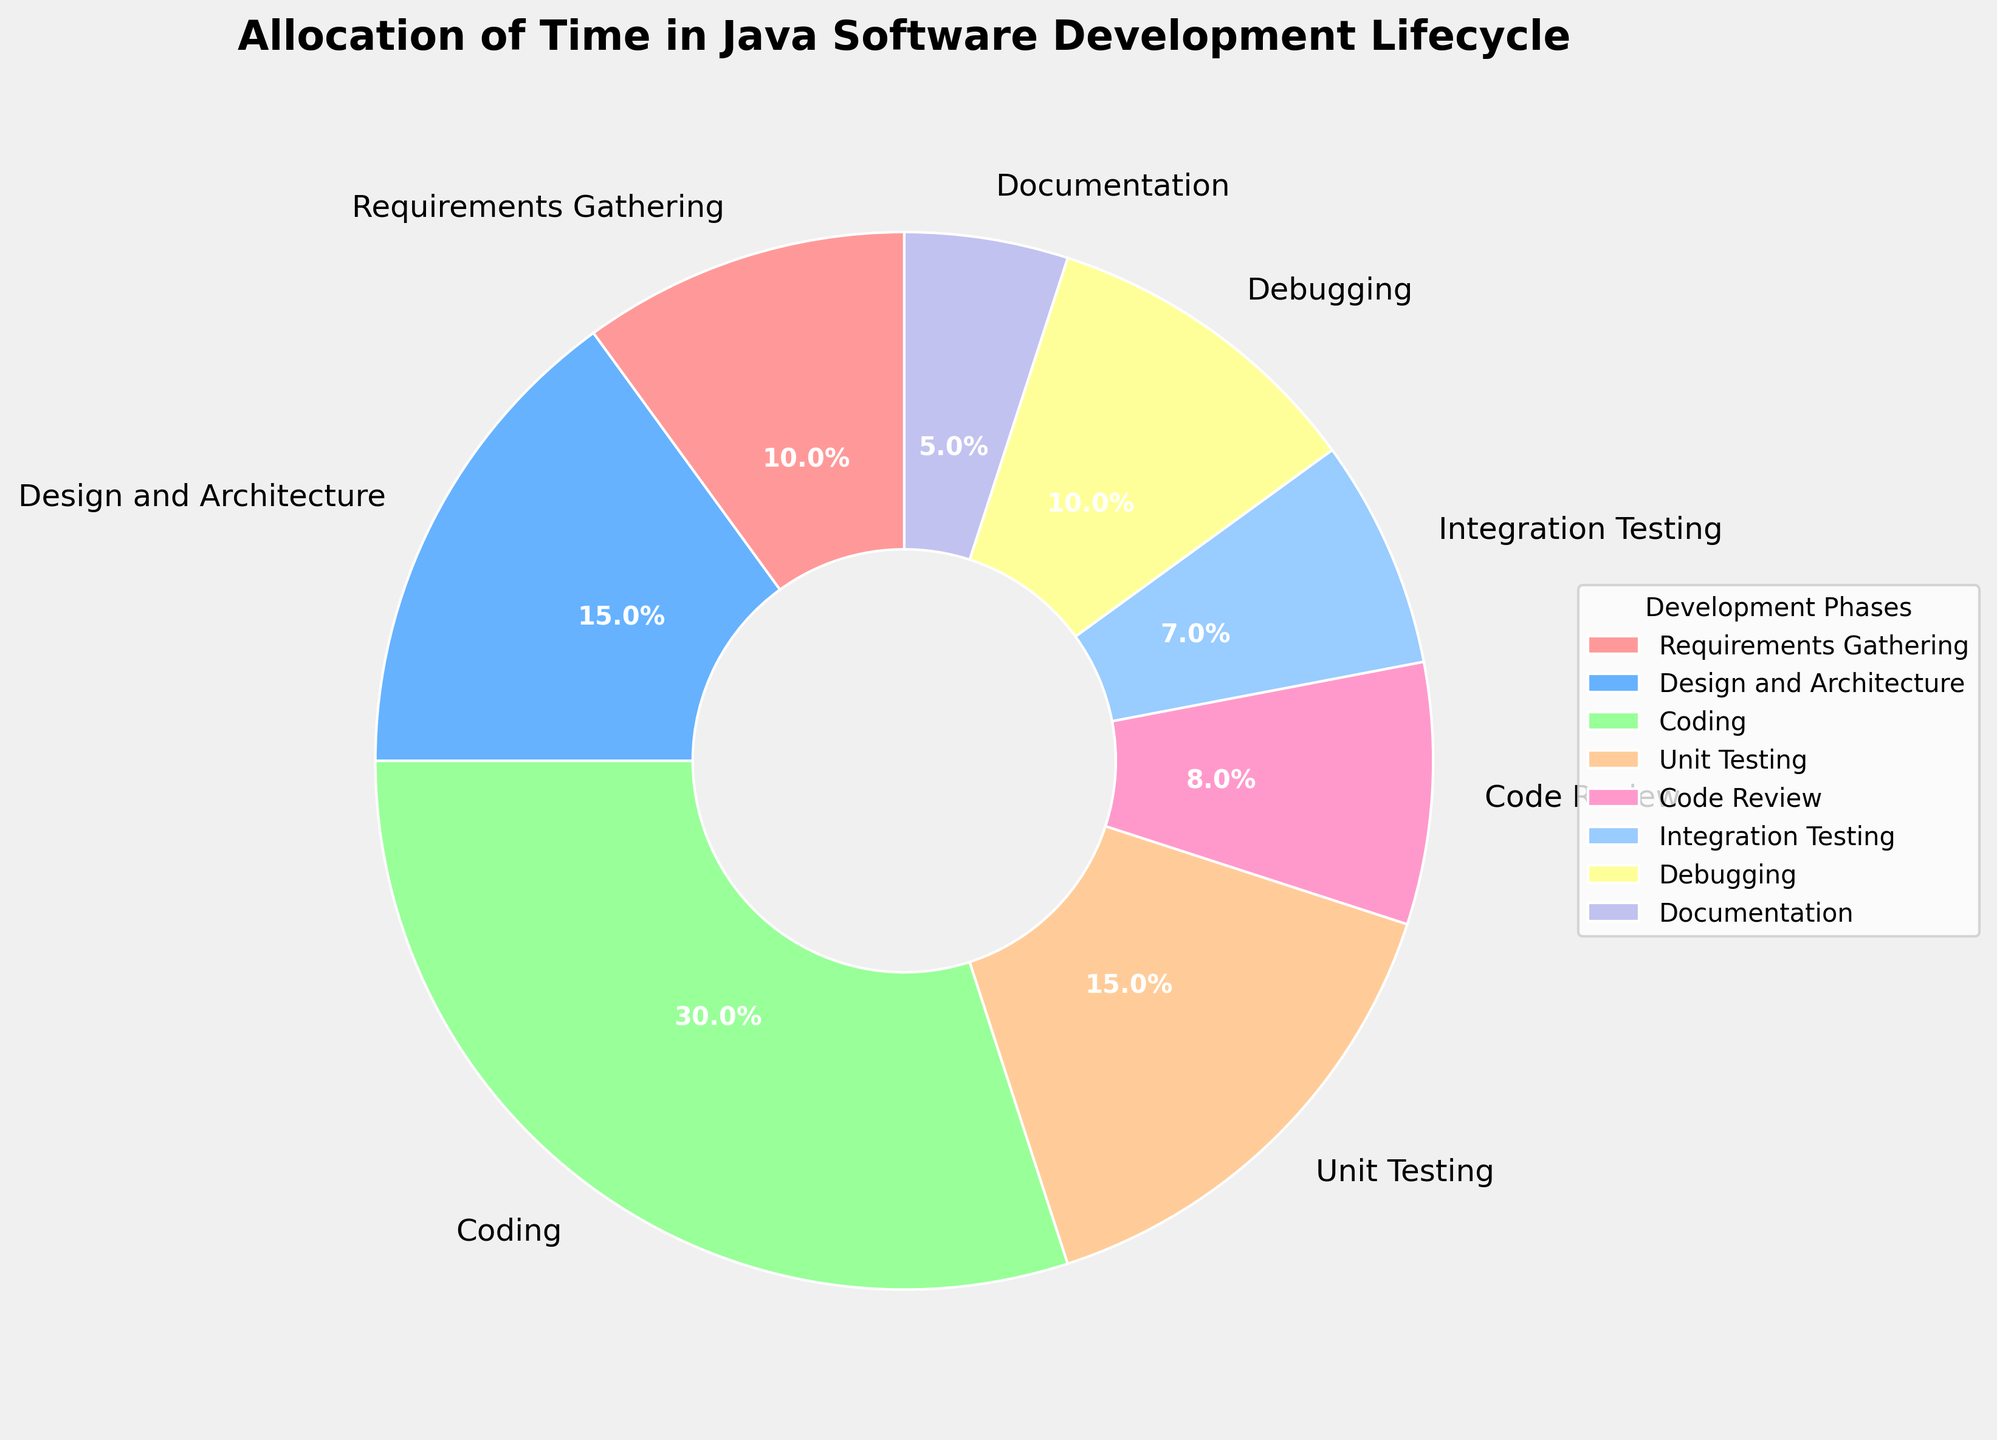What percentage of time is spent on Coding and Debugging combined? To find the percentage of time spent on Coding and Debugging combined, you add the individual percentages: 30% (Coding) + 10% (Debugging) = 40%
Answer: 40% Which phase has the least amount of time allocated? By observing the percentages in the pie chart, Documentation has the smallest percentage at 5%
Answer: Documentation How much more time is allocated to Design and Architecture compared to Integration Testing? Subtract the percentage of Integration Testing from the percentage of Design and Architecture: 15% (Design and Architecture) - 7% (Integration Testing) = 8%
Answer: 8% Are Unit Testing and Coding together allocated more or less time compared to all other phases combined? First, find the combined percentage of Unit Testing and Coding: 15% (Unit Testing) + 30% (Coding) = 45%. Then add the percentages of all other phases: 10% + 15% + 8% + 7% + 10% + 5% = 55%. Comparing 45% and 55%, we see that Unit Testing and Coding are allocated less time compared to all other phases combined
Answer: Less Which phase accounts for a greater proportion of time: Code Review or Documentation? From the percentages, Code Review accounts for 8% while Documentation accounts for 5%, so Code Review has a greater proportion of time
Answer: Code Review What is the total percentage of time allocated to testing-related phases (Unit Testing, Integration Testing, Debugging)? Add the percentages of Unit Testing, Integration Testing, and Debugging: 15% + 7% + 10% = 32%
Answer: 32% Which phase's allocation is closest to the median percentage of all phases? List all percentages: 10%, 15%, 30%, 15%, 8%, 7%, 10%, 5%. When arranged in ascending order, they are: 5%, 7%, 8%, 10%, 10%, 15%, 15%, 30%. The median of these values (since there are 8 values, average of 4th and 5th values): (10+10)/2 = 10%, so both Requirements Gathering and Debugging are closest to the median
Answer: Requirements Gathering and Debugging How does the proportion of time spent on Requirements Gathering compare to the proportion of time spent on Coding? Requirements Gathering is 10%, while Coding is 30%. To compare, the time spent on Coding is three times that of Requirements Gathering
Answer: Coding is three times more What color represents Design and Architecture in the pie chart? Observing the pie chart, the segment for Design and Architecture is represented by the second color in the custom color list which is light blue
Answer: Light blue 